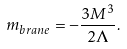<formula> <loc_0><loc_0><loc_500><loc_500>m _ { b r a n e } = - \frac { 3 M ^ { 3 } } { 2 \Lambda } .</formula> 